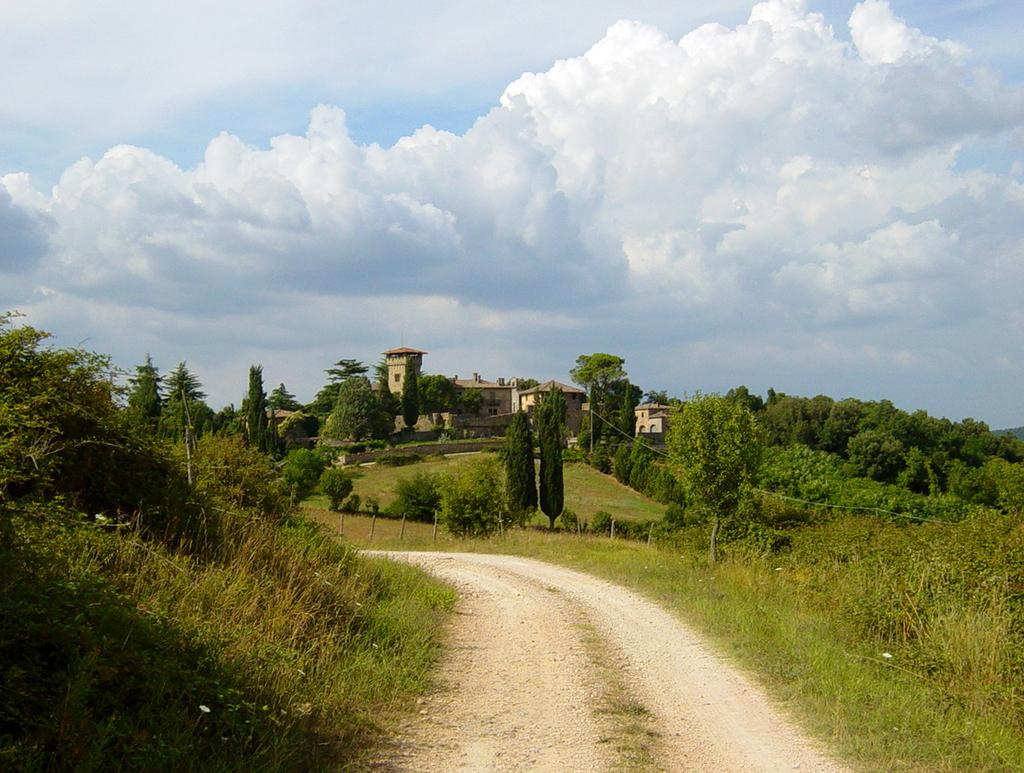What can be seen running through the image? There is a path in the image. What type of vegetation is visible near the path? Trees are visible beside the path. What type of barrier is present in the image? There is a fence in the image. What type of structures can be seen in the image? Buildings are present in the image. What type of vertical structures are visible in the image? Poles are visible in the image. What is visible in the background of the image? The sky with clouds is visible in the background of the image. Where are the tomatoes and lettuce growing in the image? There are no tomatoes or lettuce present in the image. 